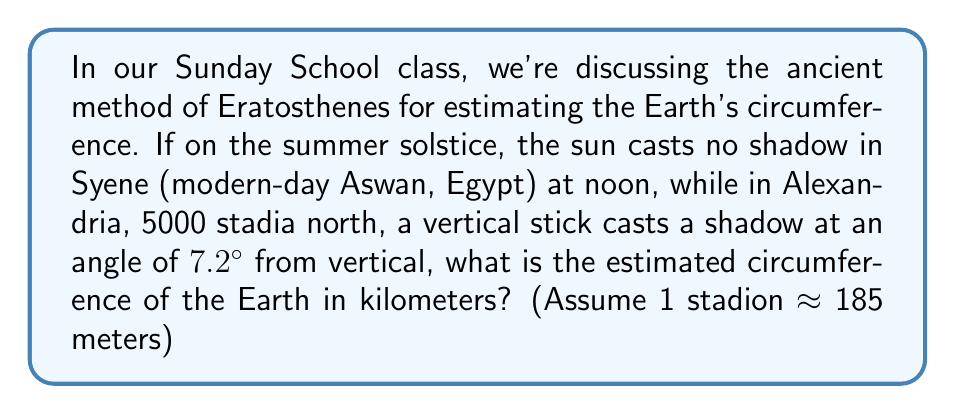Teach me how to tackle this problem. Let's approach this step-by-step, remembering that our Heavenly Father has given us the ability to understand His creations:

1) First, we need to understand that the angle at the center of the Earth is the same as the angle of the shadow in Alexandria. This is because the sun's rays are essentially parallel due to the Earth's great distance from the sun.

2) We can set up the following proportion:
   
   $\frac{\text{Angular difference}}{\text{Full circle}} = \frac{\text{Distance between cities}}{\text{Circumference of Earth}}$

3) We know:
   - Angular difference: 7.2°
   - Full circle: 360°
   - Distance between cities: 5000 stadia

4) Let's put this into our equation:

   $\frac{7.2°}{360°} = \frac{5000 \text{ stadia}}{\text{Circumference}}$

5) Cross multiply:

   $7.2 \times \text{Circumference} = 360 \times 5000 \text{ stadia}$

6) Solve for Circumference:

   $\text{Circumference} = \frac{360 \times 5000}{7.2} \text{ stadia}$

7) Calculate:

   $\text{Circumference} = 250,000 \text{ stadia}$

8) Convert to kilometers:

   $250,000 \text{ stadia} \times 185 \text{ meters/stadion} \times \frac{1 \text{ km}}{1000 \text{ m}} = 46,250 \text{ km}$

Thus, Eratosthenes' method estimates the Earth's circumference to be about 46,250 km.
Answer: 46,250 km 